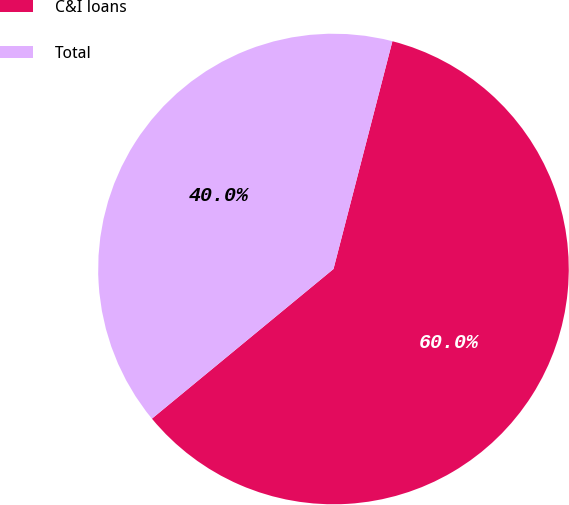Convert chart to OTSL. <chart><loc_0><loc_0><loc_500><loc_500><pie_chart><fcel>C&I loans<fcel>Total<nl><fcel>60.0%<fcel>40.0%<nl></chart> 